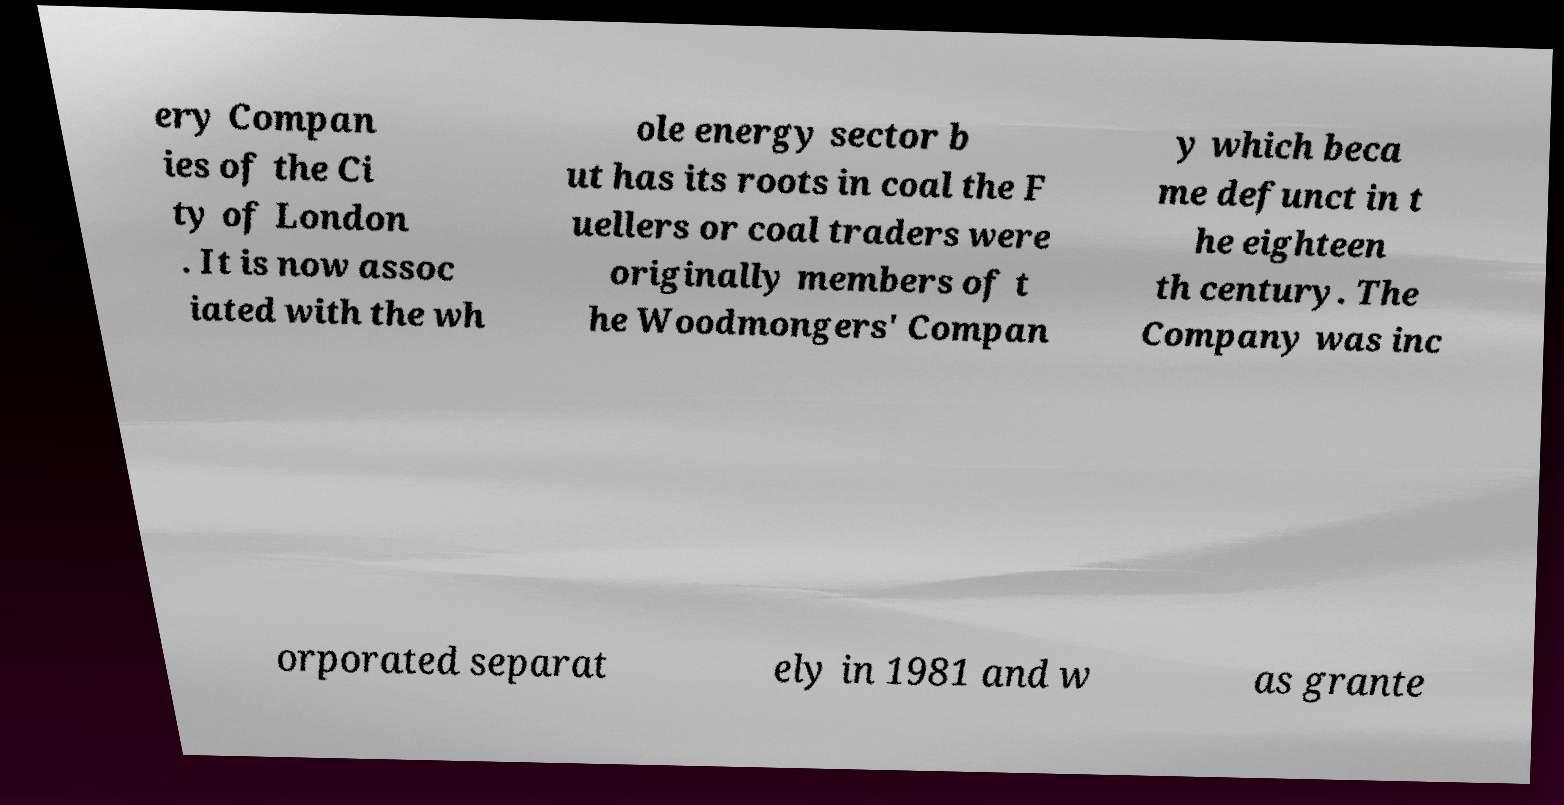Can you accurately transcribe the text from the provided image for me? ery Compan ies of the Ci ty of London . It is now assoc iated with the wh ole energy sector b ut has its roots in coal the F uellers or coal traders were originally members of t he Woodmongers' Compan y which beca me defunct in t he eighteen th century. The Company was inc orporated separat ely in 1981 and w as grante 